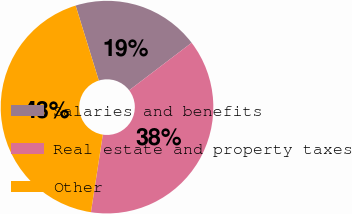Convert chart. <chart><loc_0><loc_0><loc_500><loc_500><pie_chart><fcel>Salaries and benefits<fcel>Real estate and property taxes<fcel>Other<nl><fcel>19.42%<fcel>37.77%<fcel>42.81%<nl></chart> 